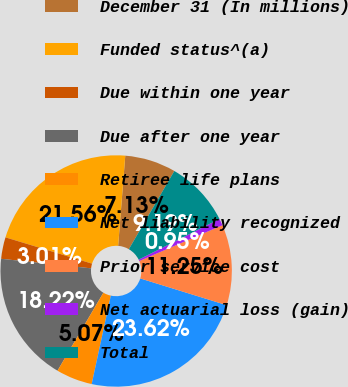Convert chart. <chart><loc_0><loc_0><loc_500><loc_500><pie_chart><fcel>December 31 (In millions)<fcel>Funded status^(a)<fcel>Due within one year<fcel>Due after one year<fcel>Retiree life plans<fcel>Net liability recognized<fcel>Prior service cost<fcel>Net actuarial loss (gain)<fcel>Total<nl><fcel>7.13%<fcel>21.56%<fcel>3.01%<fcel>18.22%<fcel>5.07%<fcel>23.62%<fcel>11.25%<fcel>0.95%<fcel>9.19%<nl></chart> 